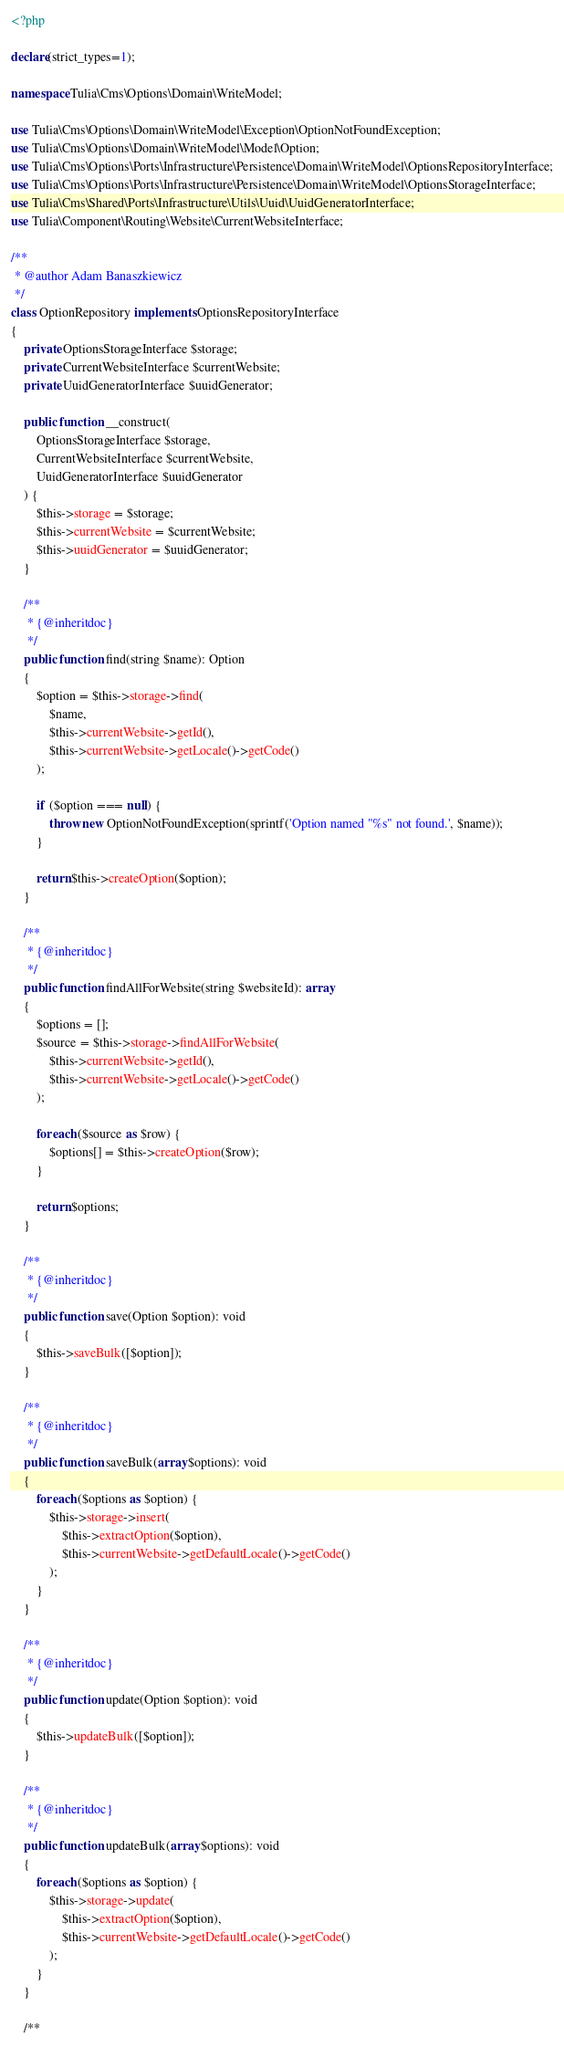<code> <loc_0><loc_0><loc_500><loc_500><_PHP_><?php

declare(strict_types=1);

namespace Tulia\Cms\Options\Domain\WriteModel;

use Tulia\Cms\Options\Domain\WriteModel\Exception\OptionNotFoundException;
use Tulia\Cms\Options\Domain\WriteModel\Model\Option;
use Tulia\Cms\Options\Ports\Infrastructure\Persistence\Domain\WriteModel\OptionsRepositoryInterface;
use Tulia\Cms\Options\Ports\Infrastructure\Persistence\Domain\WriteModel\OptionsStorageInterface;
use Tulia\Cms\Shared\Ports\Infrastructure\Utils\Uuid\UuidGeneratorInterface;
use Tulia\Component\Routing\Website\CurrentWebsiteInterface;

/**
 * @author Adam Banaszkiewicz
 */
class OptionRepository implements OptionsRepositoryInterface
{
    private OptionsStorageInterface $storage;
    private CurrentWebsiteInterface $currentWebsite;
    private UuidGeneratorInterface $uuidGenerator;

    public function __construct(
        OptionsStorageInterface $storage,
        CurrentWebsiteInterface $currentWebsite,
        UuidGeneratorInterface $uuidGenerator
    ) {
        $this->storage = $storage;
        $this->currentWebsite = $currentWebsite;
        $this->uuidGenerator = $uuidGenerator;
    }

    /**
     * {@inheritdoc}
     */
    public function find(string $name): Option
    {
        $option = $this->storage->find(
            $name,
            $this->currentWebsite->getId(),
            $this->currentWebsite->getLocale()->getCode()
        );

        if ($option === null) {
            throw new OptionNotFoundException(sprintf('Option named "%s" not found.', $name));
        }

        return $this->createOption($option);
    }

    /**
     * {@inheritdoc}
     */
    public function findAllForWebsite(string $websiteId): array
    {
        $options = [];
        $source = $this->storage->findAllForWebsite(
            $this->currentWebsite->getId(),
            $this->currentWebsite->getLocale()->getCode()
        );

        foreach ($source as $row) {
            $options[] = $this->createOption($row);
        }

        return $options;
    }

    /**
     * {@inheritdoc}
     */
    public function save(Option $option): void
    {
        $this->saveBulk([$option]);
    }

    /**
     * {@inheritdoc}
     */
    public function saveBulk(array $options): void
    {
        foreach ($options as $option) {
            $this->storage->insert(
                $this->extractOption($option),
                $this->currentWebsite->getDefaultLocale()->getCode()
            );
        }
    }

    /**
     * {@inheritdoc}
     */
    public function update(Option $option): void
    {
        $this->updateBulk([$option]);
    }

    /**
     * {@inheritdoc}
     */
    public function updateBulk(array $options): void
    {
        foreach ($options as $option) {
            $this->storage->update(
                $this->extractOption($option),
                $this->currentWebsite->getDefaultLocale()->getCode()
            );
        }
    }

    /**</code> 